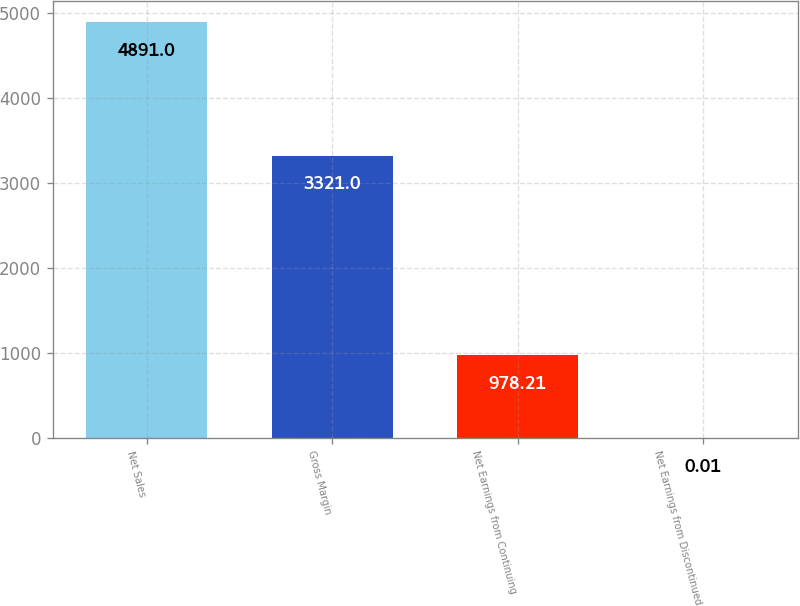Convert chart. <chart><loc_0><loc_0><loc_500><loc_500><bar_chart><fcel>Net Sales<fcel>Gross Margin<fcel>Net Earnings from Continuing<fcel>Net Earnings from Discontinued<nl><fcel>4891<fcel>3321<fcel>978.21<fcel>0.01<nl></chart> 